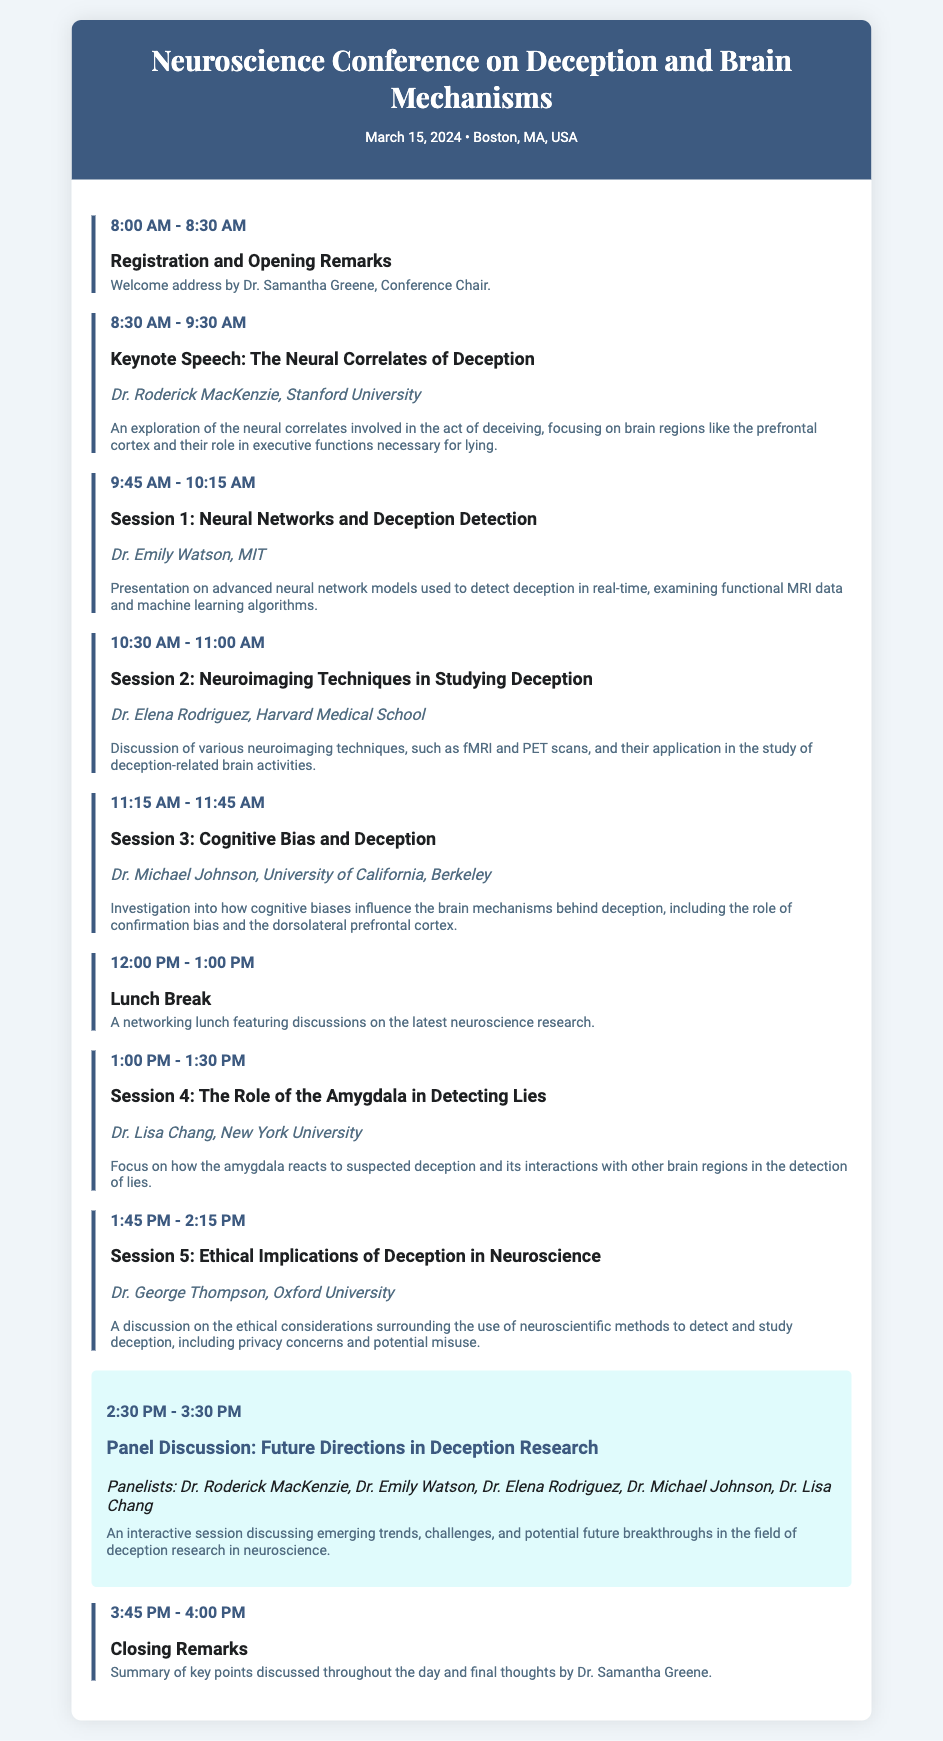What is the date of the conference? The date of the conference is provided in the event information section of the document.
Answer: March 15, 2024 Who is the keynote speaker? The keynote speaker is mentioned in the program under the title of the keynote speech.
Answer: Dr. Roderick MacKenzie What brain region is primarily discussed in the keynote speech? The abstract of the keynote speech specifies which brain region is focused on regarding deception.
Answer: Prefrontal cortex What time does registration start? The time for registration and opening remarks is indicated in the first event entry.
Answer: 8:00 AM What is the topic of Session 3? The title of Session 3 is listed in the event program section, which identifies the subject being discussed.
Answer: Cognitive Bias and Deception Which speaker discusses neuroimaging techniques? The event program lists speakers alongside their respective topics; the one mentioning neuroimaging is identifiable from these details.
Answer: Dr. Elena Rodriguez How long is the lunch break? The length of the lunch break is specified in the time section of the lunch event entry.
Answer: 1 hour What is the main focus of the panel discussion? The focus of the panel discussion is summarized in the event abstract connected to this event section.
Answer: Future Directions in Deception Research What time do the closing remarks take place? The closing remarks are detailed in the last event entry, providing the specific time for this conclusion part of the conference.
Answer: 4:00 PM 